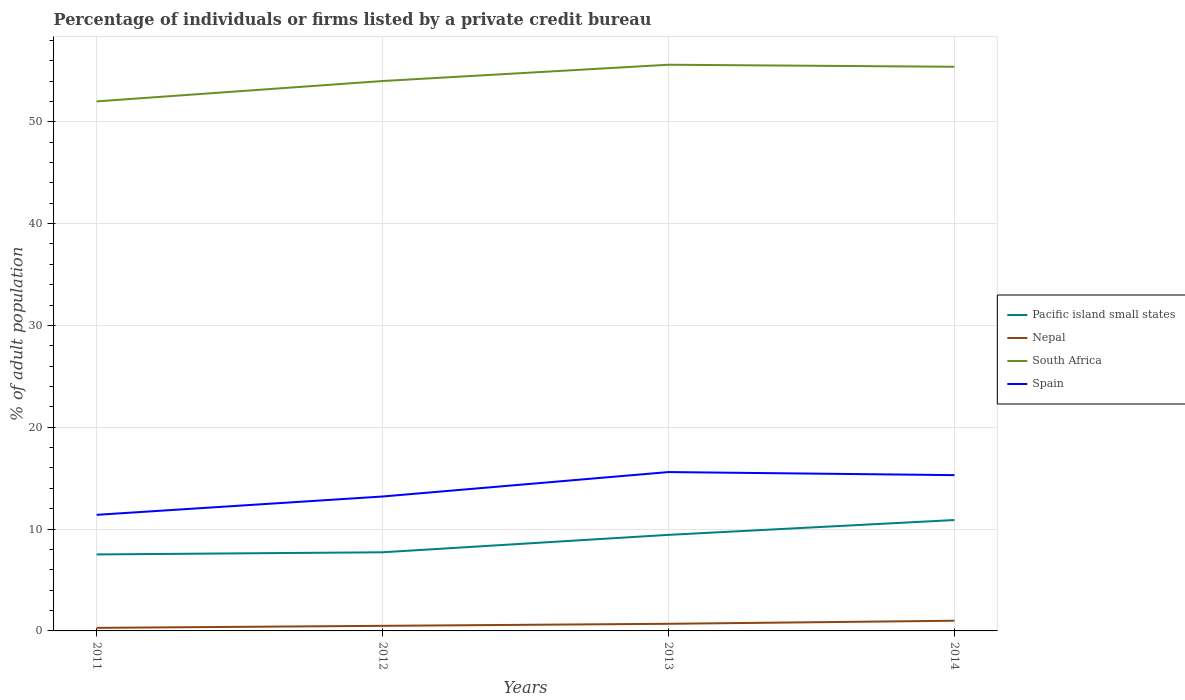How many different coloured lines are there?
Offer a terse response. 4. Does the line corresponding to Nepal intersect with the line corresponding to South Africa?
Your answer should be compact. No. Is the number of lines equal to the number of legend labels?
Your response must be concise. Yes. Across all years, what is the maximum percentage of population listed by a private credit bureau in South Africa?
Your response must be concise. 52. In which year was the percentage of population listed by a private credit bureau in Nepal maximum?
Your answer should be compact. 2011. What is the total percentage of population listed by a private credit bureau in Nepal in the graph?
Your answer should be very brief. -0.2. What is the difference between the highest and the second highest percentage of population listed by a private credit bureau in Pacific island small states?
Offer a terse response. 3.38. Is the percentage of population listed by a private credit bureau in Spain strictly greater than the percentage of population listed by a private credit bureau in South Africa over the years?
Offer a terse response. Yes. How many years are there in the graph?
Offer a very short reply. 4. Are the values on the major ticks of Y-axis written in scientific E-notation?
Offer a terse response. No. Does the graph contain any zero values?
Offer a terse response. No. Does the graph contain grids?
Ensure brevity in your answer.  Yes. What is the title of the graph?
Give a very brief answer. Percentage of individuals or firms listed by a private credit bureau. Does "Lesotho" appear as one of the legend labels in the graph?
Give a very brief answer. No. What is the label or title of the X-axis?
Offer a very short reply. Years. What is the label or title of the Y-axis?
Your answer should be compact. % of adult population. What is the % of adult population of Pacific island small states in 2011?
Your response must be concise. 7.51. What is the % of adult population of Spain in 2011?
Provide a short and direct response. 11.4. What is the % of adult population in Pacific island small states in 2012?
Keep it short and to the point. 7.72. What is the % of adult population of Nepal in 2012?
Offer a very short reply. 0.5. What is the % of adult population of Pacific island small states in 2013?
Ensure brevity in your answer.  9.43. What is the % of adult population in South Africa in 2013?
Give a very brief answer. 55.6. What is the % of adult population of Spain in 2013?
Give a very brief answer. 15.6. What is the % of adult population of Pacific island small states in 2014?
Ensure brevity in your answer.  10.89. What is the % of adult population of Nepal in 2014?
Your answer should be compact. 1. What is the % of adult population in South Africa in 2014?
Give a very brief answer. 55.4. Across all years, what is the maximum % of adult population of Pacific island small states?
Offer a very short reply. 10.89. Across all years, what is the maximum % of adult population in Nepal?
Keep it short and to the point. 1. Across all years, what is the maximum % of adult population in South Africa?
Your answer should be very brief. 55.6. Across all years, what is the minimum % of adult population in Pacific island small states?
Your answer should be very brief. 7.51. Across all years, what is the minimum % of adult population of Nepal?
Ensure brevity in your answer.  0.3. What is the total % of adult population of Pacific island small states in the graph?
Your answer should be compact. 35.56. What is the total % of adult population of South Africa in the graph?
Offer a very short reply. 217. What is the total % of adult population in Spain in the graph?
Ensure brevity in your answer.  55.5. What is the difference between the % of adult population in Pacific island small states in 2011 and that in 2012?
Offer a terse response. -0.21. What is the difference between the % of adult population in Nepal in 2011 and that in 2012?
Your answer should be very brief. -0.2. What is the difference between the % of adult population of South Africa in 2011 and that in 2012?
Give a very brief answer. -2. What is the difference between the % of adult population in Spain in 2011 and that in 2012?
Your response must be concise. -1.8. What is the difference between the % of adult population in Pacific island small states in 2011 and that in 2013?
Your answer should be compact. -1.92. What is the difference between the % of adult population of Spain in 2011 and that in 2013?
Keep it short and to the point. -4.2. What is the difference between the % of adult population of Pacific island small states in 2011 and that in 2014?
Your answer should be compact. -3.38. What is the difference between the % of adult population of Nepal in 2011 and that in 2014?
Offer a very short reply. -0.7. What is the difference between the % of adult population of South Africa in 2011 and that in 2014?
Give a very brief answer. -3.4. What is the difference between the % of adult population of Spain in 2011 and that in 2014?
Your answer should be compact. -3.9. What is the difference between the % of adult population in Pacific island small states in 2012 and that in 2013?
Your response must be concise. -1.71. What is the difference between the % of adult population of Nepal in 2012 and that in 2013?
Keep it short and to the point. -0.2. What is the difference between the % of adult population of Pacific island small states in 2012 and that in 2014?
Your response must be concise. -3.17. What is the difference between the % of adult population of Pacific island small states in 2013 and that in 2014?
Your answer should be compact. -1.46. What is the difference between the % of adult population of Nepal in 2013 and that in 2014?
Your answer should be compact. -0.3. What is the difference between the % of adult population in South Africa in 2013 and that in 2014?
Your response must be concise. 0.2. What is the difference between the % of adult population of Pacific island small states in 2011 and the % of adult population of Nepal in 2012?
Ensure brevity in your answer.  7.01. What is the difference between the % of adult population of Pacific island small states in 2011 and the % of adult population of South Africa in 2012?
Make the answer very short. -46.49. What is the difference between the % of adult population in Pacific island small states in 2011 and the % of adult population in Spain in 2012?
Give a very brief answer. -5.69. What is the difference between the % of adult population of Nepal in 2011 and the % of adult population of South Africa in 2012?
Give a very brief answer. -53.7. What is the difference between the % of adult population in Nepal in 2011 and the % of adult population in Spain in 2012?
Offer a terse response. -12.9. What is the difference between the % of adult population in South Africa in 2011 and the % of adult population in Spain in 2012?
Ensure brevity in your answer.  38.8. What is the difference between the % of adult population of Pacific island small states in 2011 and the % of adult population of Nepal in 2013?
Your answer should be compact. 6.81. What is the difference between the % of adult population in Pacific island small states in 2011 and the % of adult population in South Africa in 2013?
Your answer should be very brief. -48.09. What is the difference between the % of adult population of Pacific island small states in 2011 and the % of adult population of Spain in 2013?
Make the answer very short. -8.09. What is the difference between the % of adult population of Nepal in 2011 and the % of adult population of South Africa in 2013?
Ensure brevity in your answer.  -55.3. What is the difference between the % of adult population in Nepal in 2011 and the % of adult population in Spain in 2013?
Your answer should be very brief. -15.3. What is the difference between the % of adult population in South Africa in 2011 and the % of adult population in Spain in 2013?
Give a very brief answer. 36.4. What is the difference between the % of adult population of Pacific island small states in 2011 and the % of adult population of Nepal in 2014?
Give a very brief answer. 6.51. What is the difference between the % of adult population of Pacific island small states in 2011 and the % of adult population of South Africa in 2014?
Offer a terse response. -47.89. What is the difference between the % of adult population of Pacific island small states in 2011 and the % of adult population of Spain in 2014?
Offer a very short reply. -7.79. What is the difference between the % of adult population of Nepal in 2011 and the % of adult population of South Africa in 2014?
Your response must be concise. -55.1. What is the difference between the % of adult population in Nepal in 2011 and the % of adult population in Spain in 2014?
Your answer should be very brief. -15. What is the difference between the % of adult population in South Africa in 2011 and the % of adult population in Spain in 2014?
Provide a short and direct response. 36.7. What is the difference between the % of adult population in Pacific island small states in 2012 and the % of adult population in Nepal in 2013?
Your answer should be very brief. 7.02. What is the difference between the % of adult population in Pacific island small states in 2012 and the % of adult population in South Africa in 2013?
Offer a very short reply. -47.88. What is the difference between the % of adult population in Pacific island small states in 2012 and the % of adult population in Spain in 2013?
Give a very brief answer. -7.88. What is the difference between the % of adult population in Nepal in 2012 and the % of adult population in South Africa in 2013?
Provide a succinct answer. -55.1. What is the difference between the % of adult population in Nepal in 2012 and the % of adult population in Spain in 2013?
Your answer should be very brief. -15.1. What is the difference between the % of adult population in South Africa in 2012 and the % of adult population in Spain in 2013?
Your answer should be very brief. 38.4. What is the difference between the % of adult population of Pacific island small states in 2012 and the % of adult population of Nepal in 2014?
Provide a short and direct response. 6.72. What is the difference between the % of adult population of Pacific island small states in 2012 and the % of adult population of South Africa in 2014?
Your answer should be very brief. -47.68. What is the difference between the % of adult population of Pacific island small states in 2012 and the % of adult population of Spain in 2014?
Give a very brief answer. -7.58. What is the difference between the % of adult population of Nepal in 2012 and the % of adult population of South Africa in 2014?
Provide a succinct answer. -54.9. What is the difference between the % of adult population of Nepal in 2012 and the % of adult population of Spain in 2014?
Your answer should be compact. -14.8. What is the difference between the % of adult population of South Africa in 2012 and the % of adult population of Spain in 2014?
Make the answer very short. 38.7. What is the difference between the % of adult population in Pacific island small states in 2013 and the % of adult population in Nepal in 2014?
Offer a terse response. 8.43. What is the difference between the % of adult population of Pacific island small states in 2013 and the % of adult population of South Africa in 2014?
Your response must be concise. -45.97. What is the difference between the % of adult population of Pacific island small states in 2013 and the % of adult population of Spain in 2014?
Provide a short and direct response. -5.87. What is the difference between the % of adult population of Nepal in 2013 and the % of adult population of South Africa in 2014?
Your response must be concise. -54.7. What is the difference between the % of adult population in Nepal in 2013 and the % of adult population in Spain in 2014?
Give a very brief answer. -14.6. What is the difference between the % of adult population in South Africa in 2013 and the % of adult population in Spain in 2014?
Provide a succinct answer. 40.3. What is the average % of adult population of Pacific island small states per year?
Give a very brief answer. 8.89. What is the average % of adult population of South Africa per year?
Your answer should be very brief. 54.25. What is the average % of adult population in Spain per year?
Make the answer very short. 13.88. In the year 2011, what is the difference between the % of adult population of Pacific island small states and % of adult population of Nepal?
Provide a short and direct response. 7.21. In the year 2011, what is the difference between the % of adult population of Pacific island small states and % of adult population of South Africa?
Provide a succinct answer. -44.49. In the year 2011, what is the difference between the % of adult population of Pacific island small states and % of adult population of Spain?
Make the answer very short. -3.89. In the year 2011, what is the difference between the % of adult population in Nepal and % of adult population in South Africa?
Provide a succinct answer. -51.7. In the year 2011, what is the difference between the % of adult population in Nepal and % of adult population in Spain?
Your answer should be compact. -11.1. In the year 2011, what is the difference between the % of adult population of South Africa and % of adult population of Spain?
Your answer should be very brief. 40.6. In the year 2012, what is the difference between the % of adult population of Pacific island small states and % of adult population of Nepal?
Your answer should be very brief. 7.22. In the year 2012, what is the difference between the % of adult population of Pacific island small states and % of adult population of South Africa?
Provide a short and direct response. -46.28. In the year 2012, what is the difference between the % of adult population in Pacific island small states and % of adult population in Spain?
Make the answer very short. -5.48. In the year 2012, what is the difference between the % of adult population of Nepal and % of adult population of South Africa?
Ensure brevity in your answer.  -53.5. In the year 2012, what is the difference between the % of adult population in South Africa and % of adult population in Spain?
Make the answer very short. 40.8. In the year 2013, what is the difference between the % of adult population in Pacific island small states and % of adult population in Nepal?
Make the answer very short. 8.73. In the year 2013, what is the difference between the % of adult population of Pacific island small states and % of adult population of South Africa?
Offer a terse response. -46.17. In the year 2013, what is the difference between the % of adult population of Pacific island small states and % of adult population of Spain?
Your answer should be compact. -6.17. In the year 2013, what is the difference between the % of adult population of Nepal and % of adult population of South Africa?
Make the answer very short. -54.9. In the year 2013, what is the difference between the % of adult population in Nepal and % of adult population in Spain?
Ensure brevity in your answer.  -14.9. In the year 2013, what is the difference between the % of adult population of South Africa and % of adult population of Spain?
Make the answer very short. 40. In the year 2014, what is the difference between the % of adult population in Pacific island small states and % of adult population in Nepal?
Keep it short and to the point. 9.89. In the year 2014, what is the difference between the % of adult population of Pacific island small states and % of adult population of South Africa?
Offer a very short reply. -44.51. In the year 2014, what is the difference between the % of adult population in Pacific island small states and % of adult population in Spain?
Offer a terse response. -4.41. In the year 2014, what is the difference between the % of adult population in Nepal and % of adult population in South Africa?
Make the answer very short. -54.4. In the year 2014, what is the difference between the % of adult population of Nepal and % of adult population of Spain?
Provide a succinct answer. -14.3. In the year 2014, what is the difference between the % of adult population in South Africa and % of adult population in Spain?
Provide a short and direct response. 40.1. What is the ratio of the % of adult population in Pacific island small states in 2011 to that in 2012?
Offer a very short reply. 0.97. What is the ratio of the % of adult population in Nepal in 2011 to that in 2012?
Your response must be concise. 0.6. What is the ratio of the % of adult population of South Africa in 2011 to that in 2012?
Offer a terse response. 0.96. What is the ratio of the % of adult population of Spain in 2011 to that in 2012?
Your response must be concise. 0.86. What is the ratio of the % of adult population in Pacific island small states in 2011 to that in 2013?
Make the answer very short. 0.8. What is the ratio of the % of adult population of Nepal in 2011 to that in 2013?
Provide a short and direct response. 0.43. What is the ratio of the % of adult population of South Africa in 2011 to that in 2013?
Your response must be concise. 0.94. What is the ratio of the % of adult population in Spain in 2011 to that in 2013?
Your answer should be very brief. 0.73. What is the ratio of the % of adult population in Pacific island small states in 2011 to that in 2014?
Your response must be concise. 0.69. What is the ratio of the % of adult population in South Africa in 2011 to that in 2014?
Your response must be concise. 0.94. What is the ratio of the % of adult population in Spain in 2011 to that in 2014?
Your response must be concise. 0.75. What is the ratio of the % of adult population in Pacific island small states in 2012 to that in 2013?
Provide a short and direct response. 0.82. What is the ratio of the % of adult population of Nepal in 2012 to that in 2013?
Give a very brief answer. 0.71. What is the ratio of the % of adult population of South Africa in 2012 to that in 2013?
Give a very brief answer. 0.97. What is the ratio of the % of adult population of Spain in 2012 to that in 2013?
Your response must be concise. 0.85. What is the ratio of the % of adult population of Pacific island small states in 2012 to that in 2014?
Offer a very short reply. 0.71. What is the ratio of the % of adult population of Nepal in 2012 to that in 2014?
Offer a terse response. 0.5. What is the ratio of the % of adult population of South Africa in 2012 to that in 2014?
Your answer should be very brief. 0.97. What is the ratio of the % of adult population of Spain in 2012 to that in 2014?
Ensure brevity in your answer.  0.86. What is the ratio of the % of adult population in Pacific island small states in 2013 to that in 2014?
Give a very brief answer. 0.87. What is the ratio of the % of adult population of Nepal in 2013 to that in 2014?
Your answer should be very brief. 0.7. What is the ratio of the % of adult population of Spain in 2013 to that in 2014?
Your answer should be very brief. 1.02. What is the difference between the highest and the second highest % of adult population in Pacific island small states?
Keep it short and to the point. 1.46. What is the difference between the highest and the second highest % of adult population in Spain?
Your response must be concise. 0.3. What is the difference between the highest and the lowest % of adult population in Pacific island small states?
Offer a terse response. 3.38. What is the difference between the highest and the lowest % of adult population in Spain?
Keep it short and to the point. 4.2. 